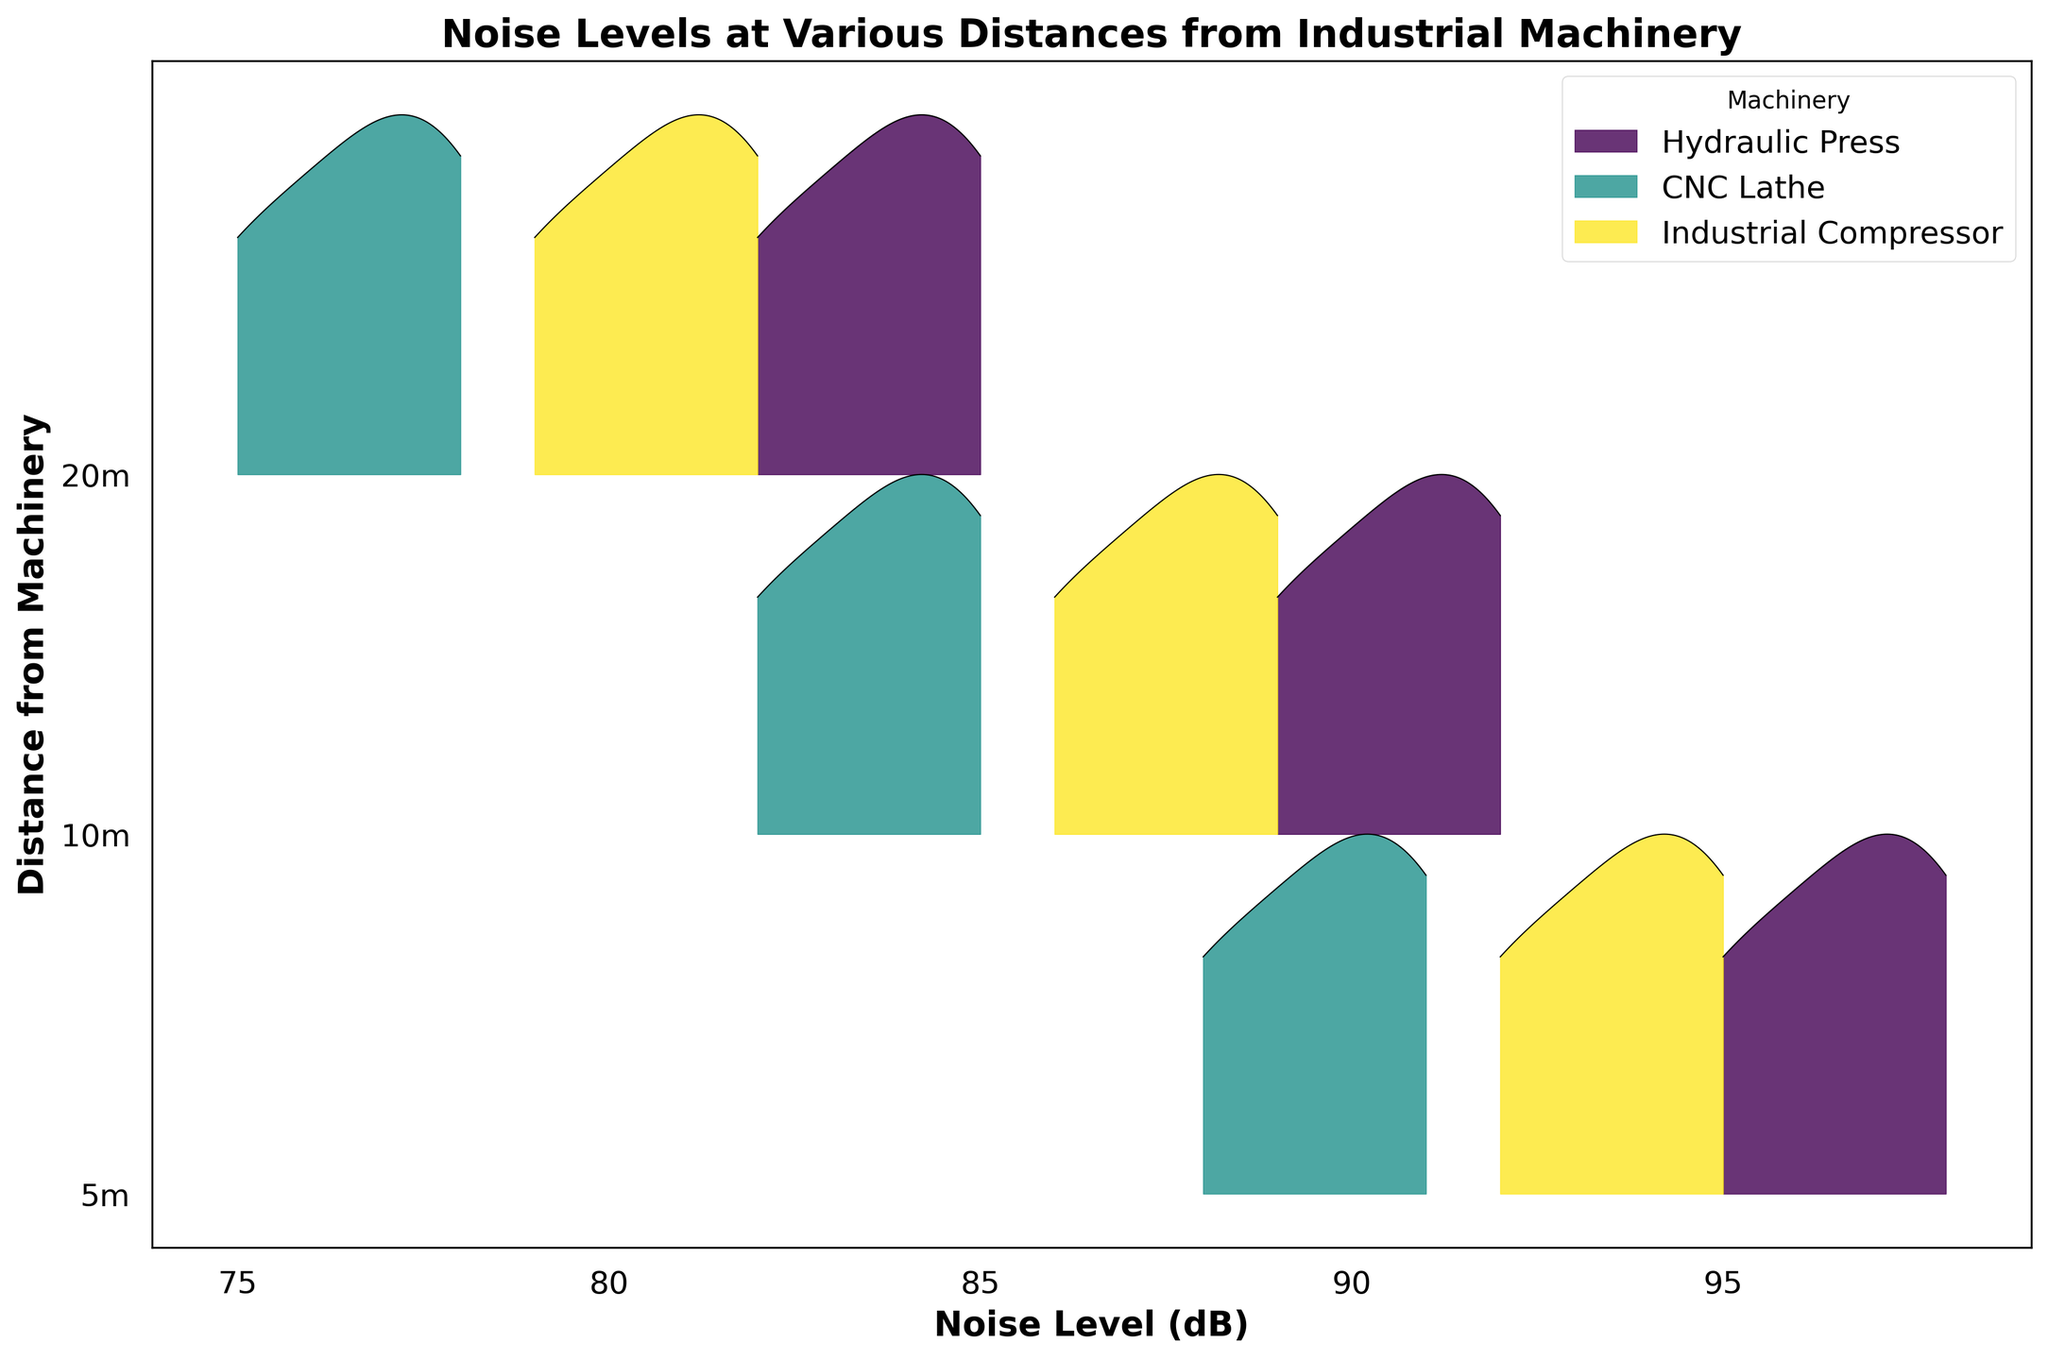what is the title of the figure? The title is displayed at the top of the figure. It should give a general idea about the data being visualized.
Answer: Noise Levels at Various Distances from Industrial Machinery what are the x and y axes labeled as? The x-axis represents the variable being measured, and the y-axis indicates the categories or groups.
Answer: The x-axis is labeled 'Noise Level (dB)' and the y-axis is labeled 'Distance from Machinery' which machinery has the highest noise level at 5m distance? Look at the ridgeline plot for the noise levels at 5m distance. The highest peak among the different machines at 5m shows the highest noise level.
Answer: Hydraulic Press how does the noise level of the hydraulic press at 10m compare to the CNC lathe at the same distance? Compare the peaks of the ridgeline plots for the hydraulic press and CNC lathe at 10m. Check which one is higher.
Answer: Higher for the Hydraulic Press which machine shows the most significant change in noise level from 5m to 20m? Observe the changes in the distribution peaks of each machine from 5m to 20m. The machine with the largest difference in peak heights indicates the most significant change.
Answer: Industrial Compressor what is the general trend of noise levels as distance increases? Analyze the ridgeline plots for each machine and observe the pattern of the peaks as distance goes from 5m to 20m. Identify if they generally increase, decrease, or remain stable.
Answer: Decrease what is the noise level range for the CNC lathe at 5m? Look at the x-axis values that the ridgeline plot for the CNC lathe at 5m covers. This range represents the variation in noise levels.
Answer: 88 to 91 dB how consistent are the noise levels for the industrial compressor across different distances? Check the spread and peaks of the ridgeline plots for the industrial compressor at various distances. Consistency is reflected by similar peak heights and positions.
Answer: Relatively consistent what are the y-ticks representing on this ridgeline plot? The y-ticks on the y-axis represent different categories or groups in the data, which in this case are the distances from the machinery.
Answer: Distances from machinery (5m, 10m, 20m) 